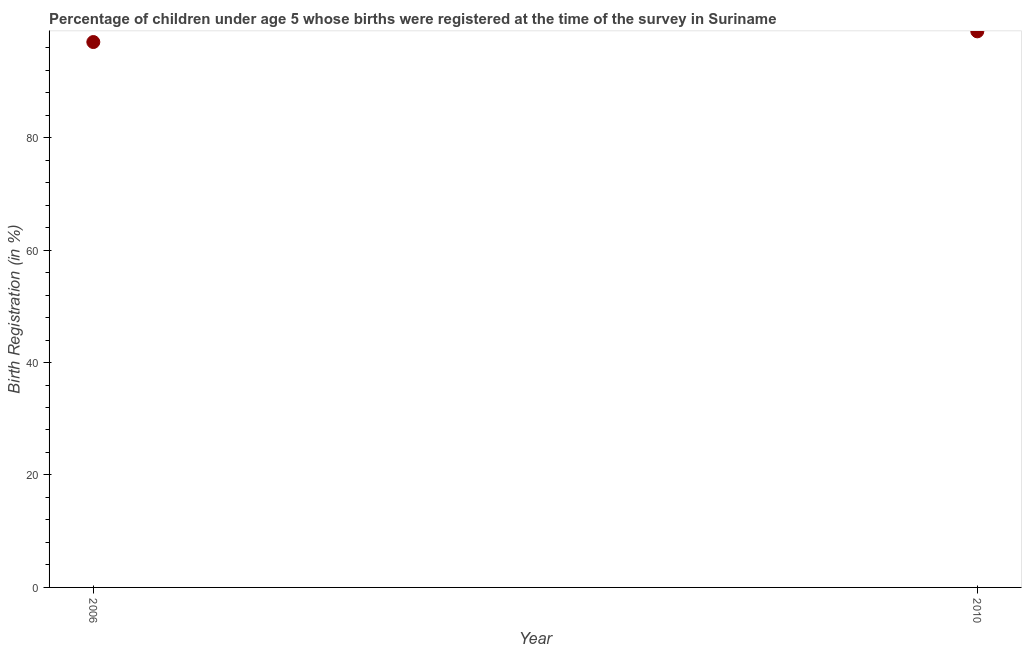What is the birth registration in 2010?
Keep it short and to the point. 98.9. Across all years, what is the maximum birth registration?
Give a very brief answer. 98.9. Across all years, what is the minimum birth registration?
Ensure brevity in your answer.  97. In which year was the birth registration maximum?
Give a very brief answer. 2010. In which year was the birth registration minimum?
Keep it short and to the point. 2006. What is the sum of the birth registration?
Offer a very short reply. 195.9. What is the difference between the birth registration in 2006 and 2010?
Your answer should be compact. -1.9. What is the average birth registration per year?
Give a very brief answer. 97.95. What is the median birth registration?
Provide a succinct answer. 97.95. What is the ratio of the birth registration in 2006 to that in 2010?
Provide a succinct answer. 0.98. Is the birth registration in 2006 less than that in 2010?
Give a very brief answer. Yes. In how many years, is the birth registration greater than the average birth registration taken over all years?
Your answer should be compact. 1. What is the difference between two consecutive major ticks on the Y-axis?
Your answer should be very brief. 20. Does the graph contain any zero values?
Keep it short and to the point. No. Does the graph contain grids?
Give a very brief answer. No. What is the title of the graph?
Your answer should be very brief. Percentage of children under age 5 whose births were registered at the time of the survey in Suriname. What is the label or title of the Y-axis?
Your response must be concise. Birth Registration (in %). What is the Birth Registration (in %) in 2006?
Provide a short and direct response. 97. What is the Birth Registration (in %) in 2010?
Your response must be concise. 98.9. What is the ratio of the Birth Registration (in %) in 2006 to that in 2010?
Ensure brevity in your answer.  0.98. 